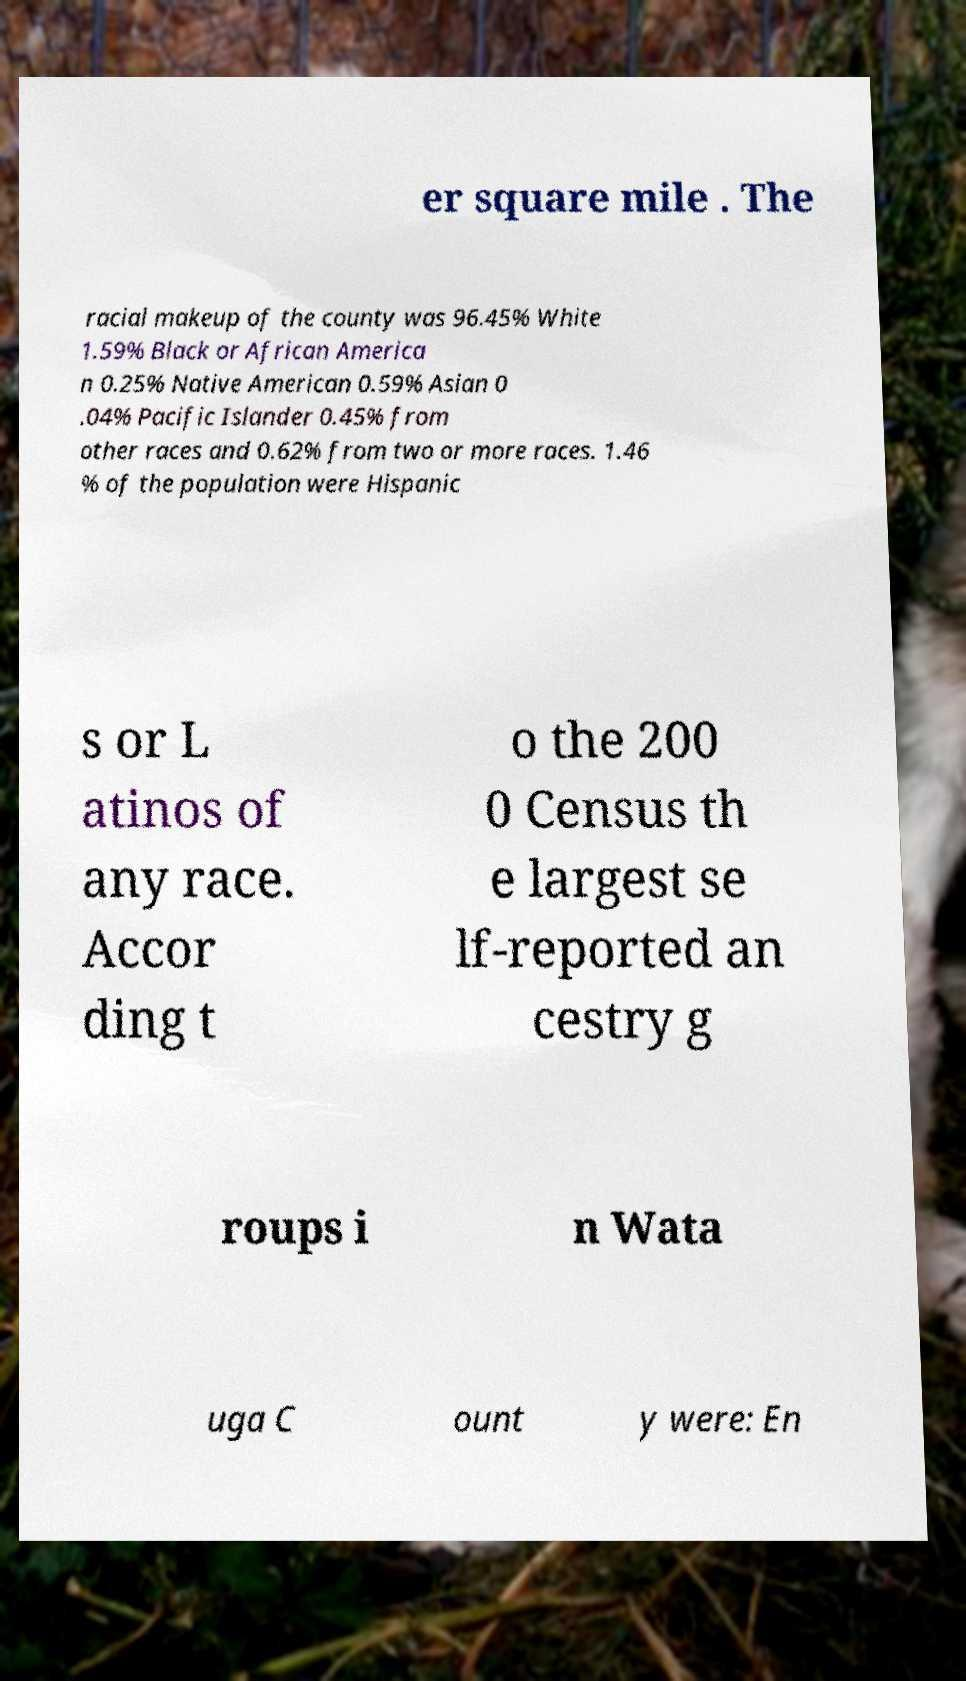Could you assist in decoding the text presented in this image and type it out clearly? er square mile . The racial makeup of the county was 96.45% White 1.59% Black or African America n 0.25% Native American 0.59% Asian 0 .04% Pacific Islander 0.45% from other races and 0.62% from two or more races. 1.46 % of the population were Hispanic s or L atinos of any race. Accor ding t o the 200 0 Census th e largest se lf-reported an cestry g roups i n Wata uga C ount y were: En 